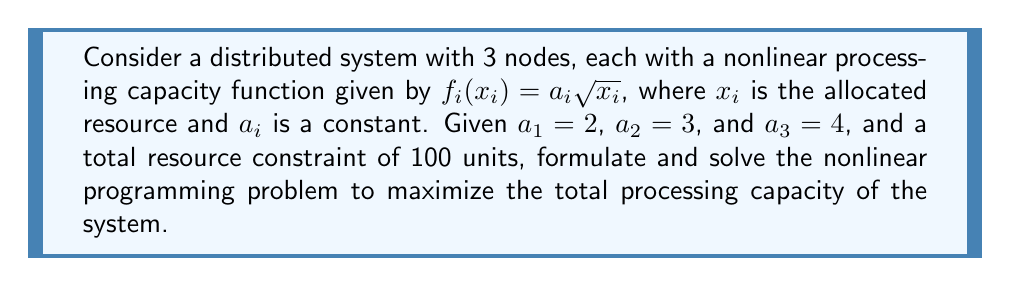Could you help me with this problem? 1. Formulate the objective function:
   Maximize $Z = f_1(x_1) + f_2(x_2) + f_3(x_3) = 2\sqrt{x_1} + 3\sqrt{x_2} + 4\sqrt{x_3}$

2. Define constraints:
   $x_1 + x_2 + x_3 = 100$
   $x_1, x_2, x_3 \geq 0$

3. Apply the method of Lagrange multipliers:
   $L(x_1, x_2, x_3, \lambda) = 2\sqrt{x_1} + 3\sqrt{x_2} + 4\sqrt{x_3} - \lambda(x_1 + x_2 + x_3 - 100)$

4. Find partial derivatives and set them to zero:
   $\frac{\partial L}{\partial x_1} = \frac{1}{\sqrt{x_1}} - \lambda = 0$
   $\frac{\partial L}{\partial x_2} = \frac{3}{2\sqrt{x_2}} - \lambda = 0$
   $\frac{\partial L}{\partial x_3} = \frac{2}{\sqrt{x_3}} - \lambda = 0$
   $\frac{\partial L}{\partial \lambda} = x_1 + x_2 + x_3 - 100 = 0$

5. Solve the system of equations:
   From the first three equations:
   $x_1 = \frac{1}{\lambda^2}$
   $x_2 = \frac{9}{4\lambda^2}$
   $x_3 = \frac{4}{\lambda^2}$

   Substituting into the fourth equation:
   $\frac{1}{\lambda^2} + \frac{9}{4\lambda^2} + \frac{4}{\lambda^2} = 100$
   $\frac{25}{4\lambda^2} = 100$
   $\lambda^2 = \frac{1}{16}$
   $\lambda = \frac{1}{4}$

6. Calculate optimal resource allocation:
   $x_1 = \frac{1}{(1/4)^2} = 16$
   $x_2 = \frac{9}{4(1/4)^2} = 36$
   $x_3 = \frac{4}{(1/4)^2} = 64$

7. Verify the solution:
   $16 + 36 + 64 = 100$ (constraint satisfied)
   $Z = 2\sqrt{16} + 3\sqrt{36} + 4\sqrt{64} = 8 + 18 + 32 = 58$
Answer: $x_1 = 16, x_2 = 36, x_3 = 64$ 